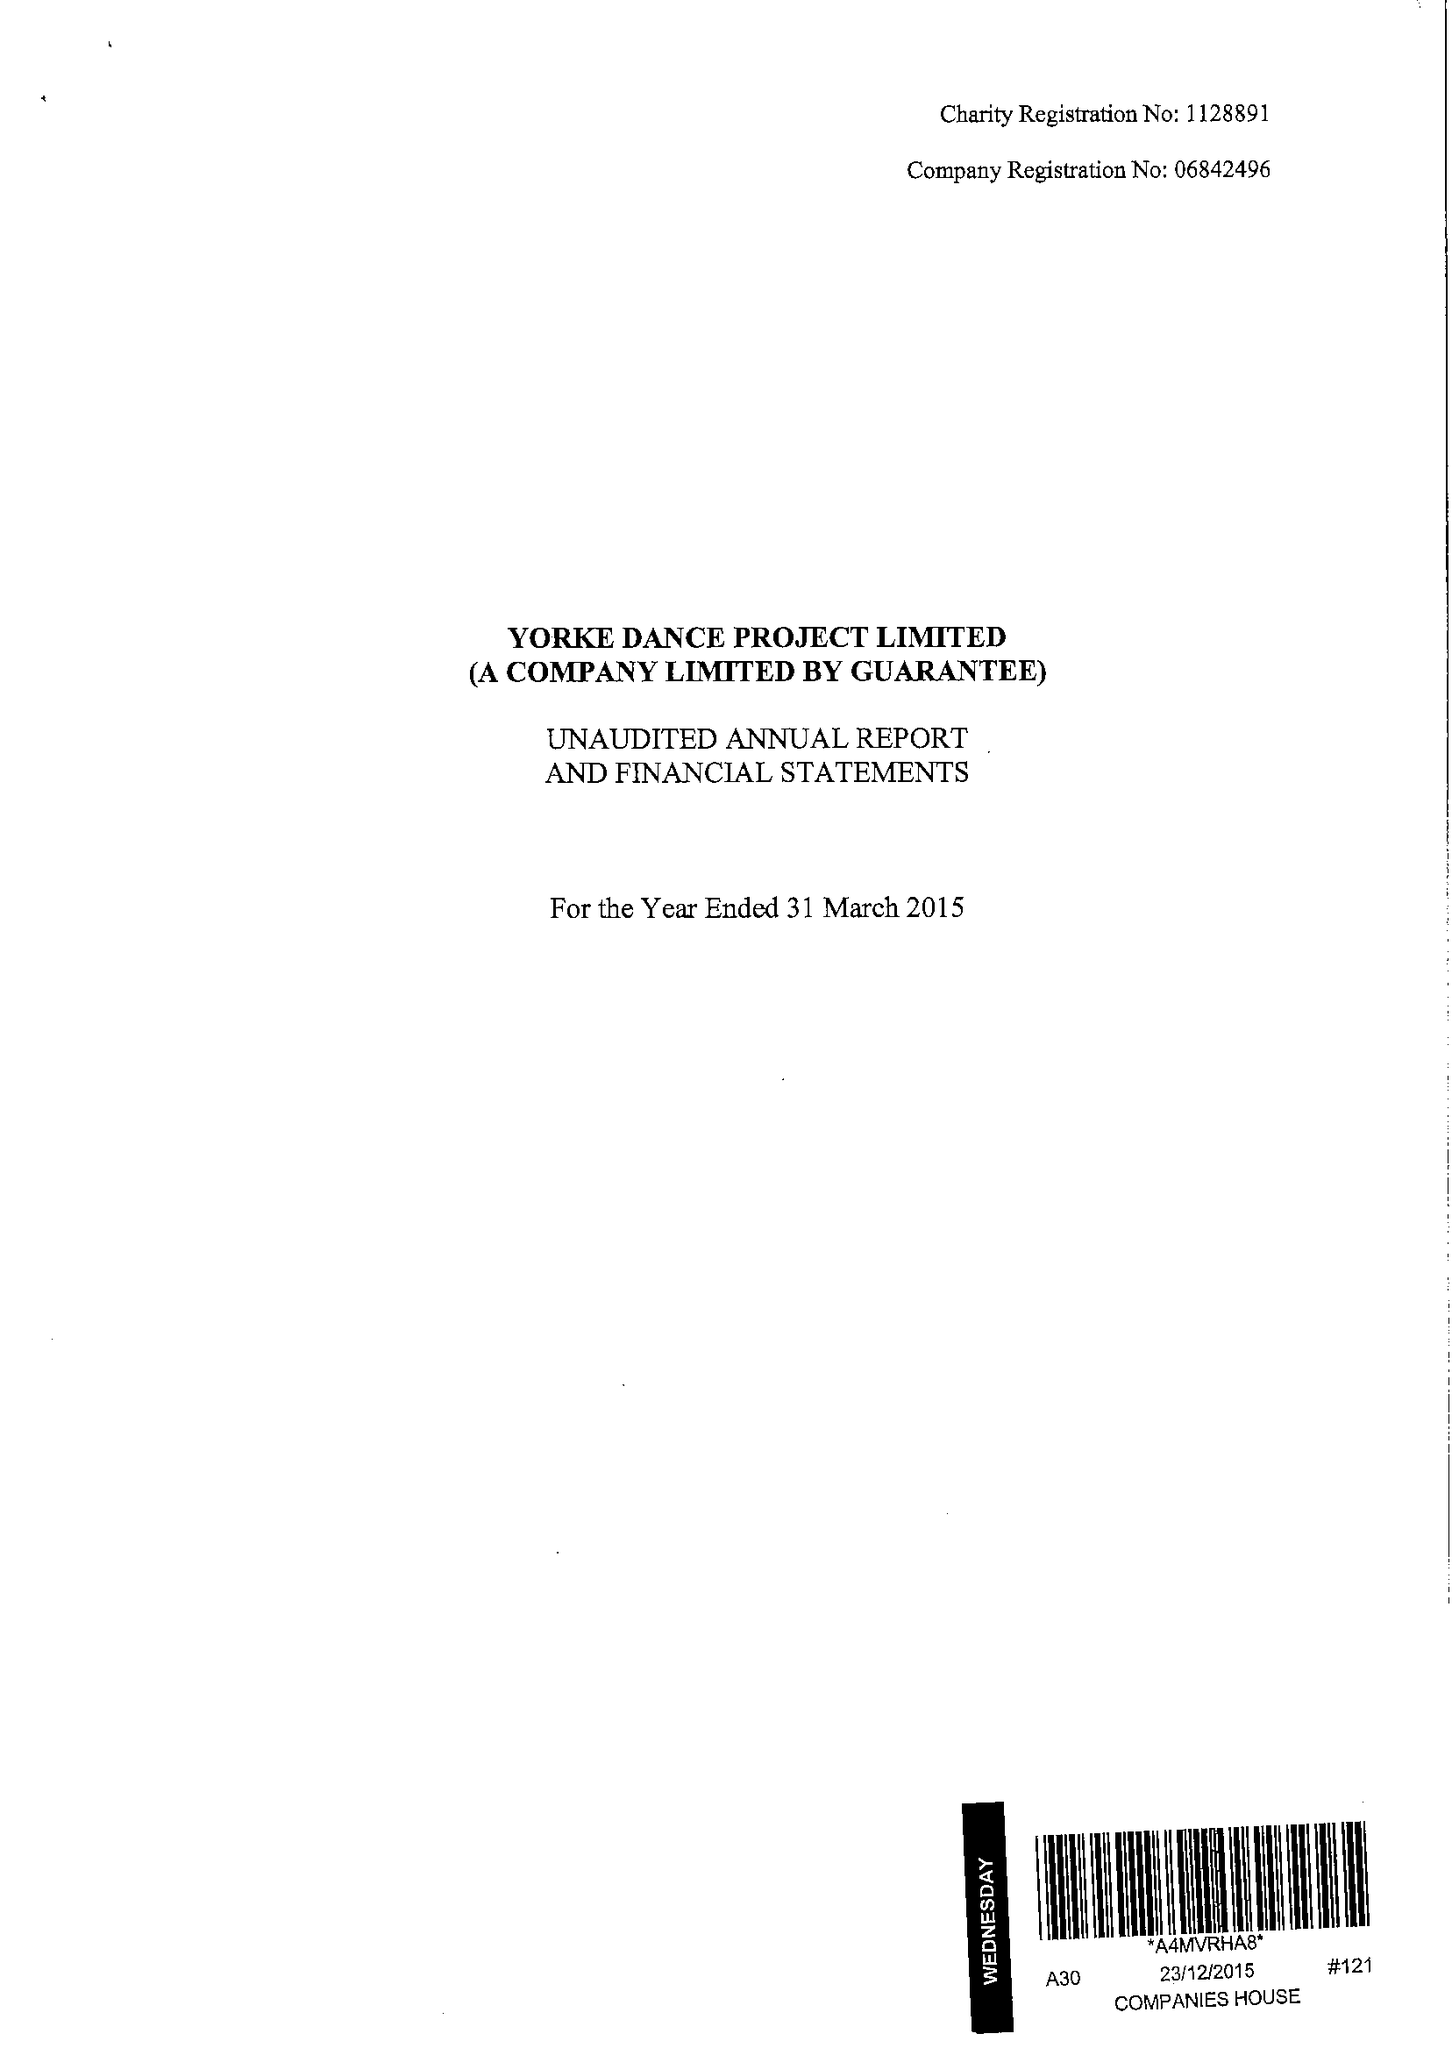What is the value for the spending_annually_in_british_pounds?
Answer the question using a single word or phrase. 134744.00 